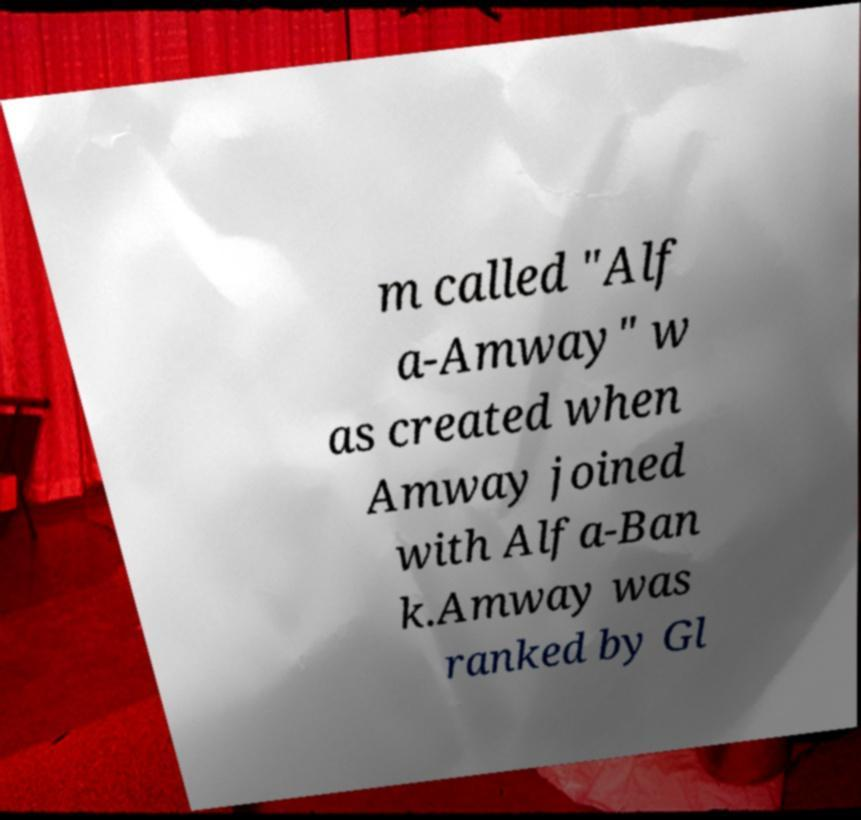Can you accurately transcribe the text from the provided image for me? m called "Alf a-Amway" w as created when Amway joined with Alfa-Ban k.Amway was ranked by Gl 